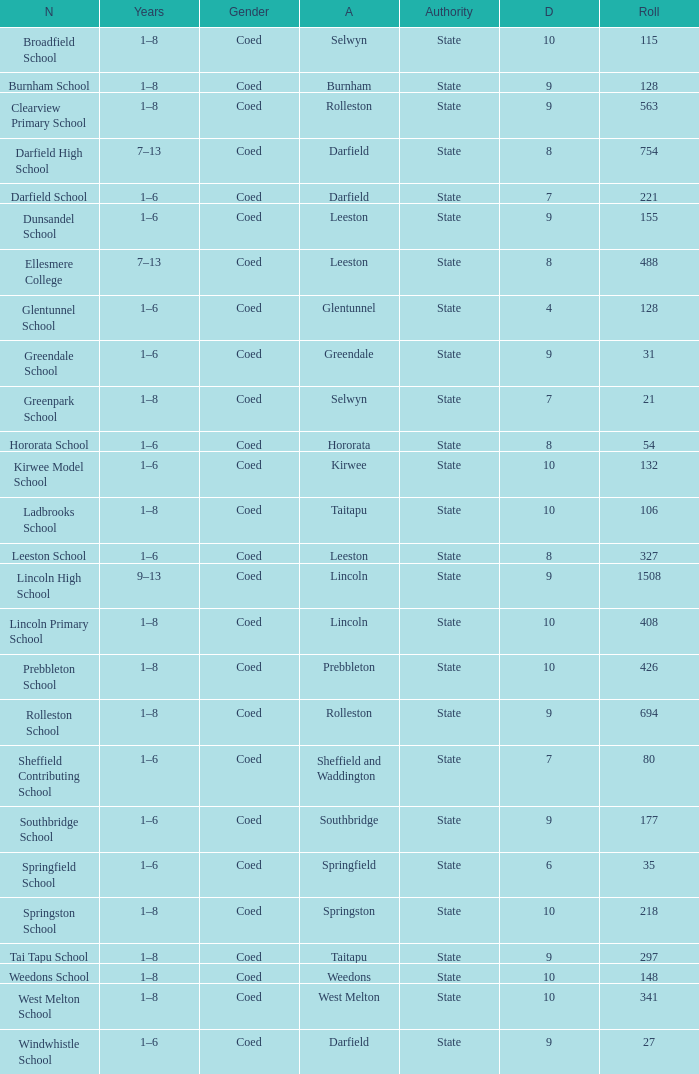Which years have a Name of ladbrooks school? 1–8. 